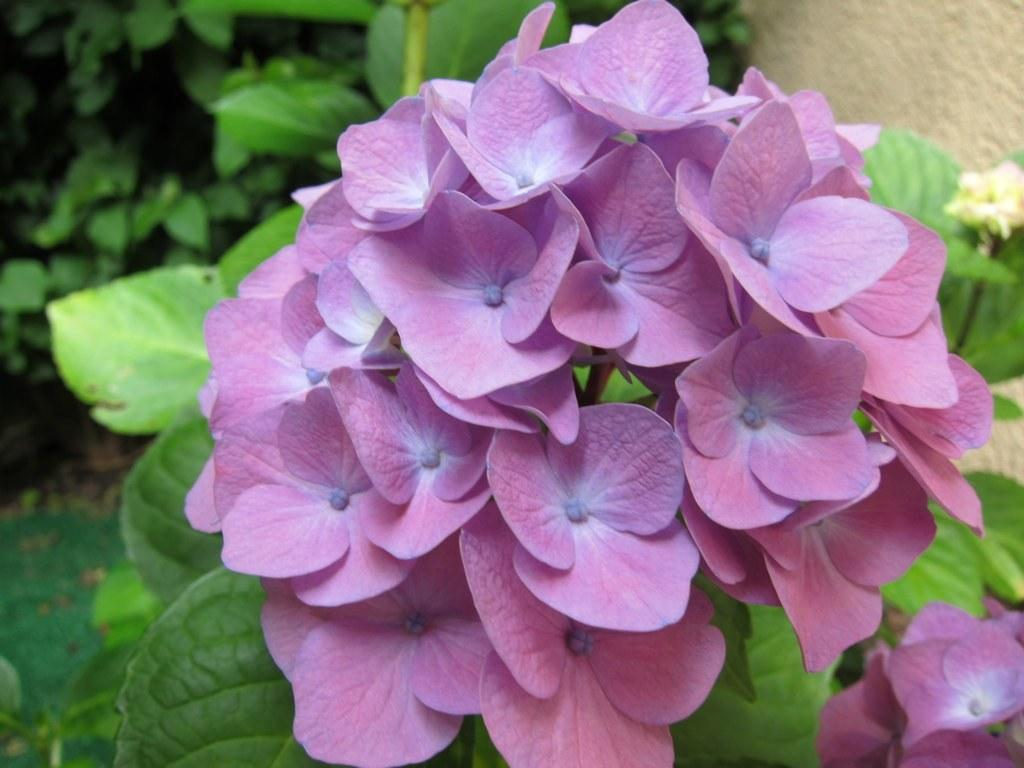What type of living organisms can be seen in the foreground of the image? There are flowers on a plant in the foreground of the image. What can be seen in the background of the image? There are plants visible in the background of the image, and there is also a wall. Can you describe the plants in the image? The plants in the image are in the foreground and background, with flowers on the plant in the foreground. How much smoke can be seen coming from the flowers in the image? There is no smoke present in the image; it features flowers on a plant in the foreground and plants in the background. What season is depicted in the image, considering the presence of flowers? The image does not provide enough information to determine the season, as flowers can bloom in various seasons. 